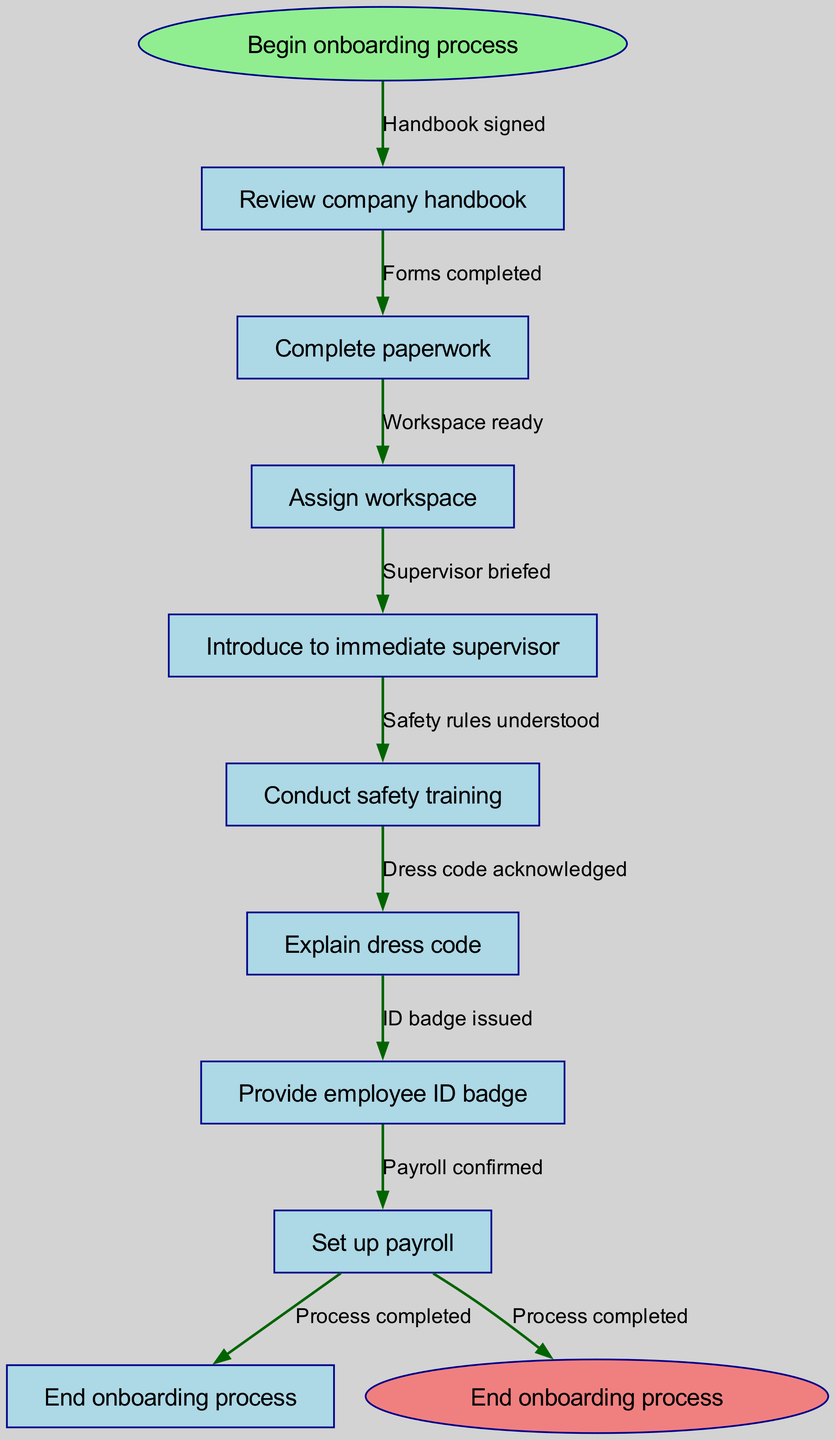What is the first step in the onboarding process? The diagram indicates that the first step is labeled as the "Begin onboarding process," which is the starting node leading into the onboarding flow.
Answer: Begin onboarding process How many total nodes are present in the diagram? To calculate the total number of nodes, count the starting and ending nodes, plus the process nodes in between. There are 1 start node, 8 process nodes, and 1 end node which gives a total of 10 nodes.
Answer: 10 What node follows "Complete paperwork"? The next node after "Complete paperwork" is determined by following the edge leading from that node to the subsequent process node, which is "Assign workspace."
Answer: Assign workspace Which node is the last step before concluding the onboarding process? Check the flow from the end node back to find the last performing task, which shows that the node before reaching the endpoint is "Set up payroll."
Answer: Set up payroll What is the total number of edges in the diagram? Edges can be counted by identifying the connections between each node. Since there is one edge leading from the start node to the first process node and then one edge for each transition until reaching the end, the total comes to 9 edges.
Answer: 9 Which two nodes are connected by the edge labeled "ID badge issued"? To answer this, identify the nodes involved in the edge description "ID badge issued." This edge connects "Provide employee ID badge" to the next node, which is "Set up payroll."
Answer: Provide employee ID badge and Set up payroll What does the last edge labeled "Process completed" signify? The last edge indicates the successful transition from the penultimate process node "Set up payroll" to the end node of the diagram, which denotes that the onboarding process is completed.
Answer: Onboarding process completed What is the relationship between "Explain dress code" and "Conduct safety training"? The relationship can be understood by observing the flow; both are part of the onboarding sequence, but "Conduct safety training" occurs before "Explain dress code" in the onboarding procedure.
Answer: Sequentially related Which node directly follows "Introduce to immediate supervisor"? The flowchart shows that after "Introduce to immediate supervisor," the next activity is "Conduct safety training," illustrating the order of operations during onboarding.
Answer: Conduct safety training 